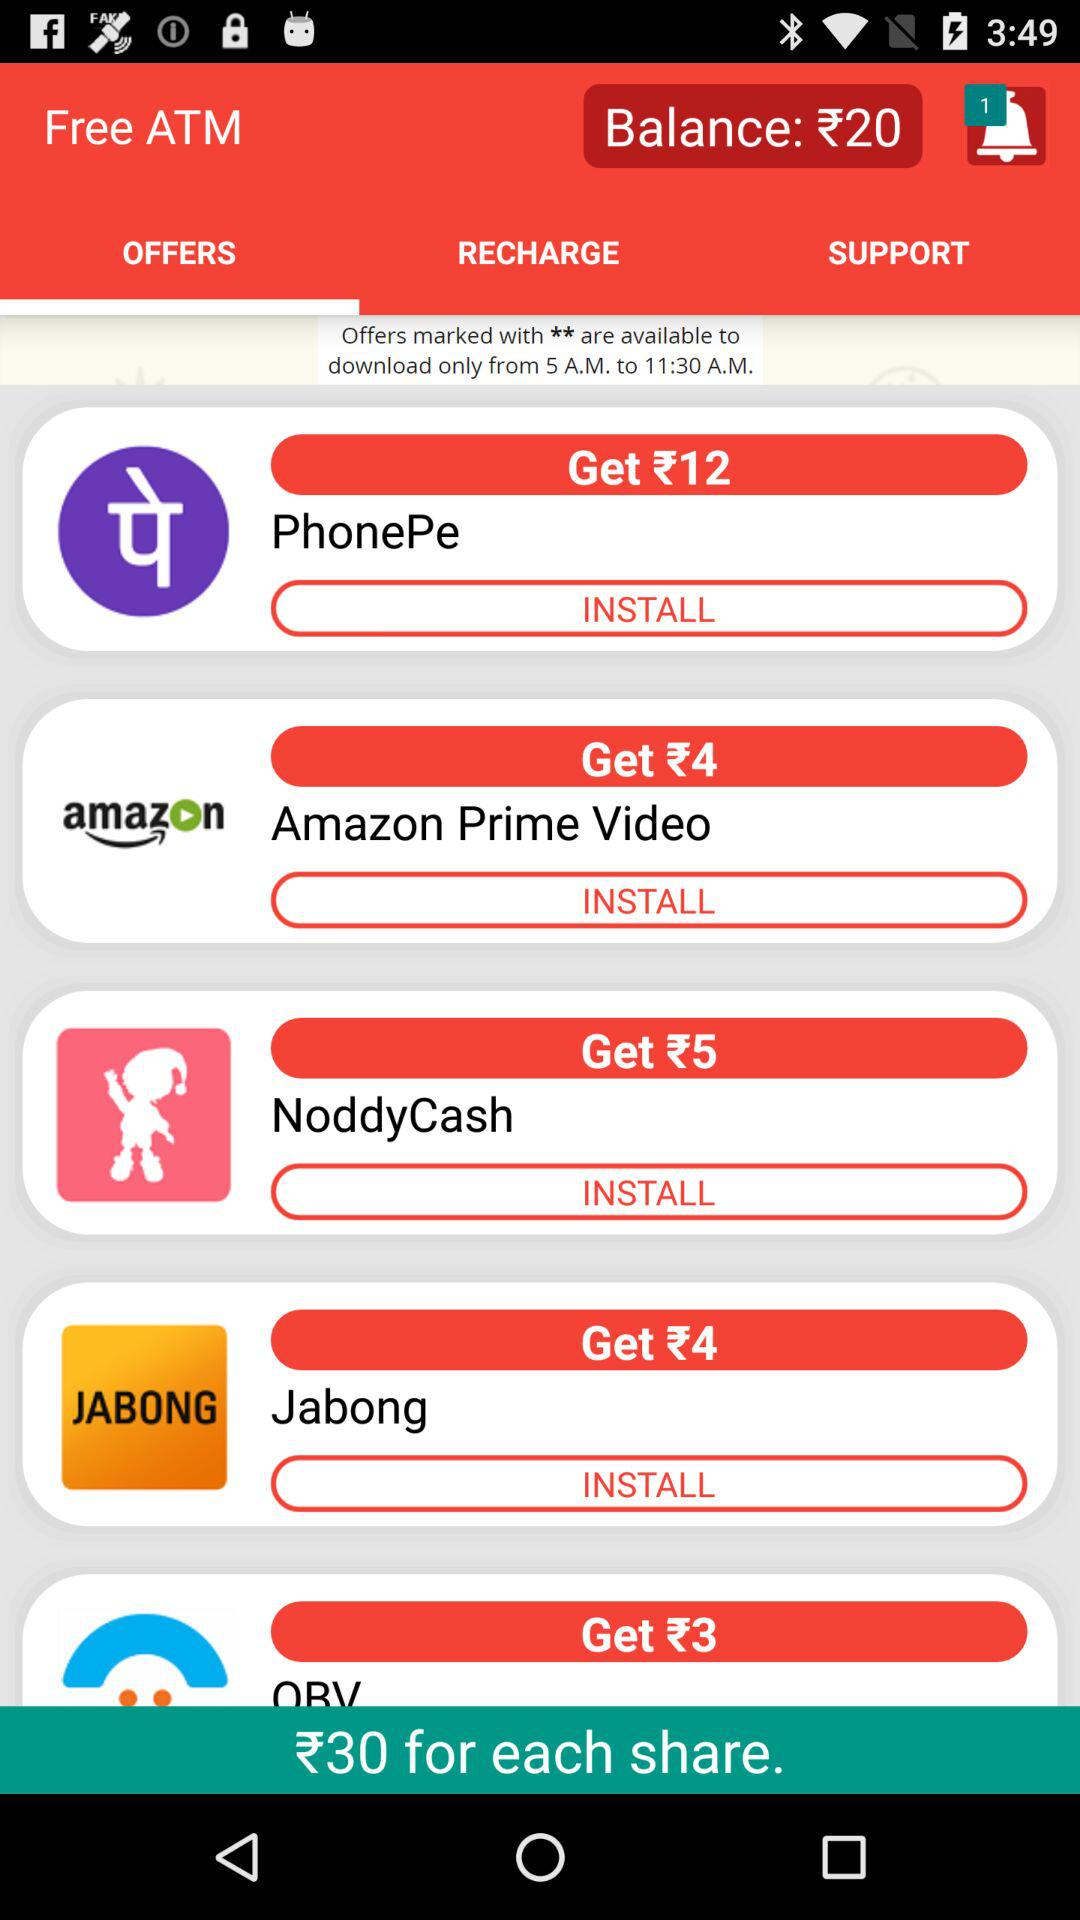What will we get for installing "NoddyCash"? You will get ₹5 for installing "NoddyCash". 